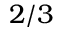Convert formula to latex. <formula><loc_0><loc_0><loc_500><loc_500>2 / 3</formula> 